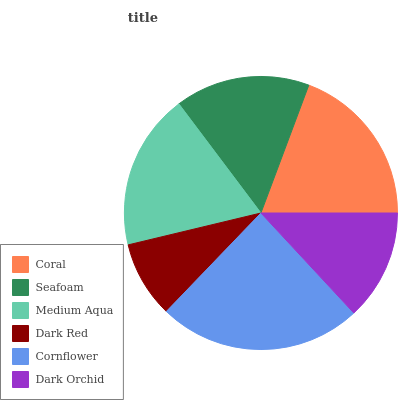Is Dark Red the minimum?
Answer yes or no. Yes. Is Cornflower the maximum?
Answer yes or no. Yes. Is Seafoam the minimum?
Answer yes or no. No. Is Seafoam the maximum?
Answer yes or no. No. Is Coral greater than Seafoam?
Answer yes or no. Yes. Is Seafoam less than Coral?
Answer yes or no. Yes. Is Seafoam greater than Coral?
Answer yes or no. No. Is Coral less than Seafoam?
Answer yes or no. No. Is Medium Aqua the high median?
Answer yes or no. Yes. Is Seafoam the low median?
Answer yes or no. Yes. Is Coral the high median?
Answer yes or no. No. Is Coral the low median?
Answer yes or no. No. 